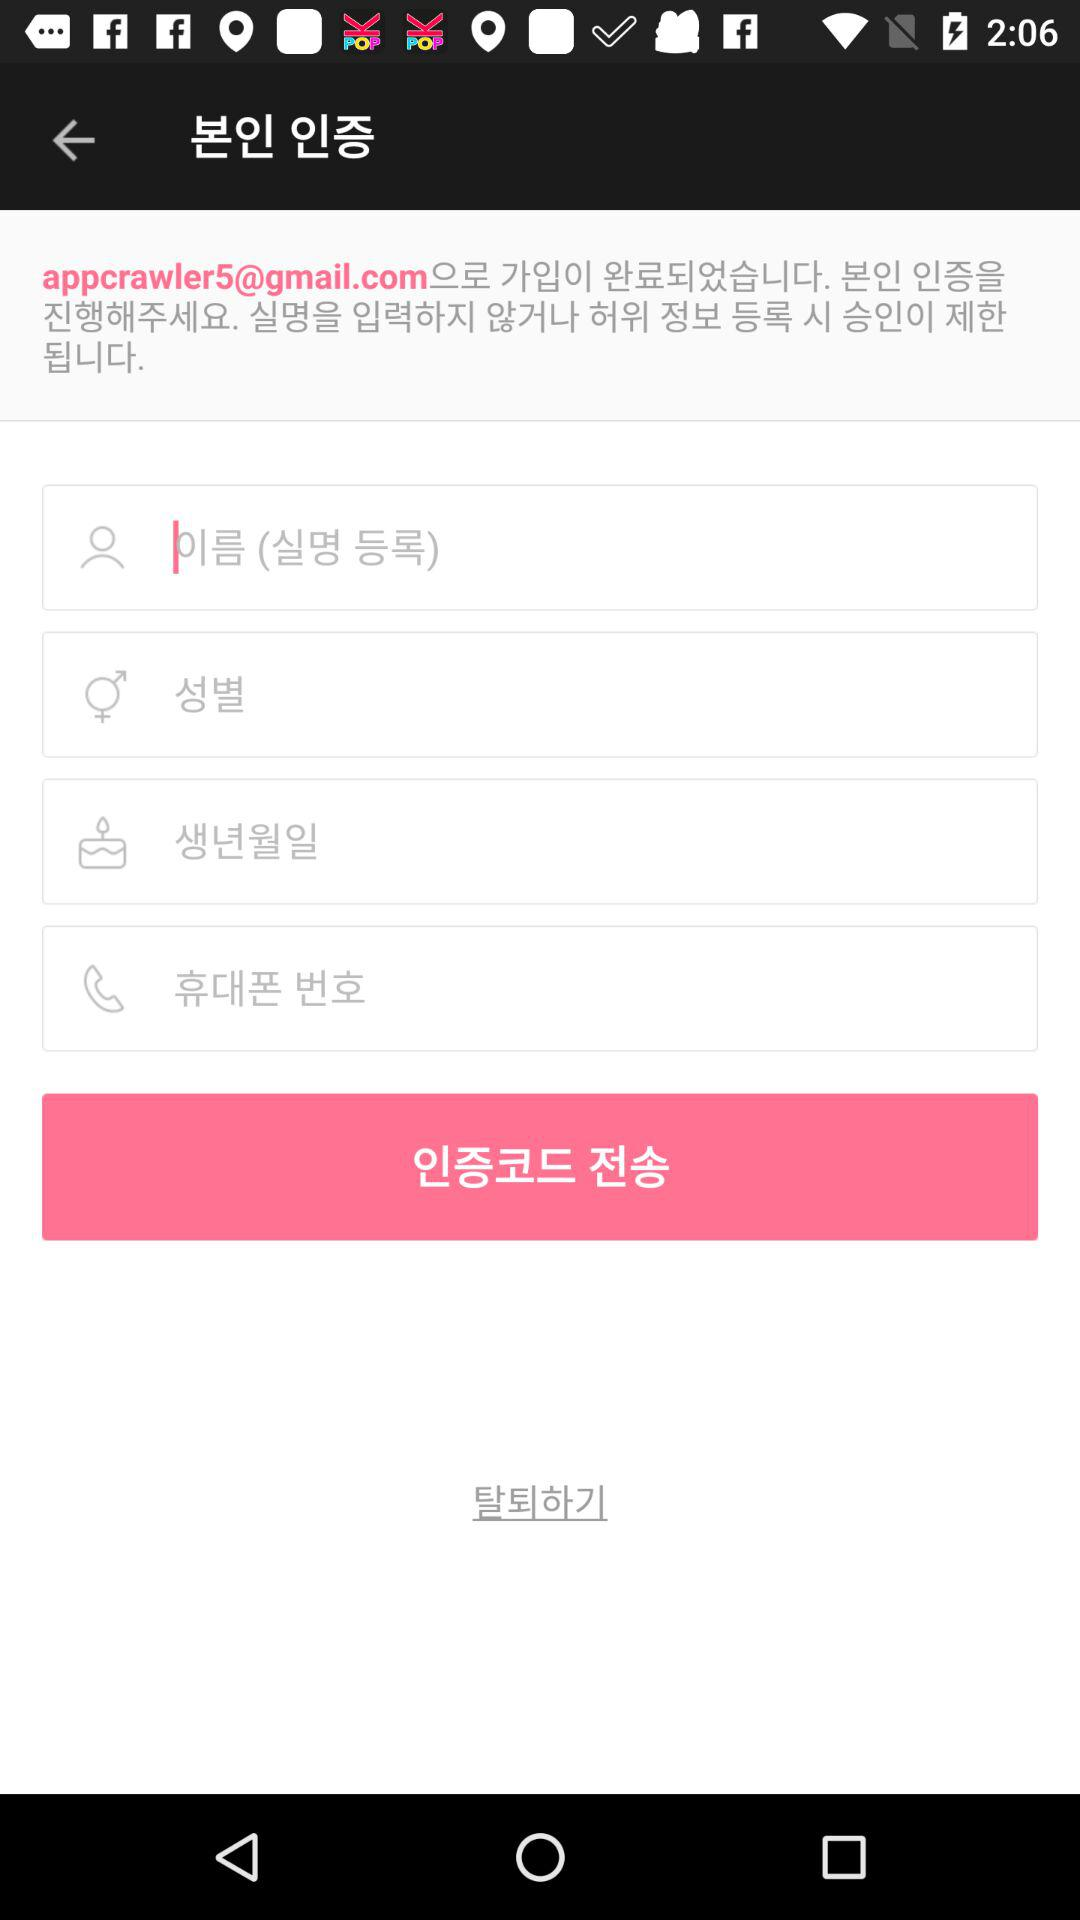How many text fields are there for entering personal information?
Answer the question using a single word or phrase. 4 